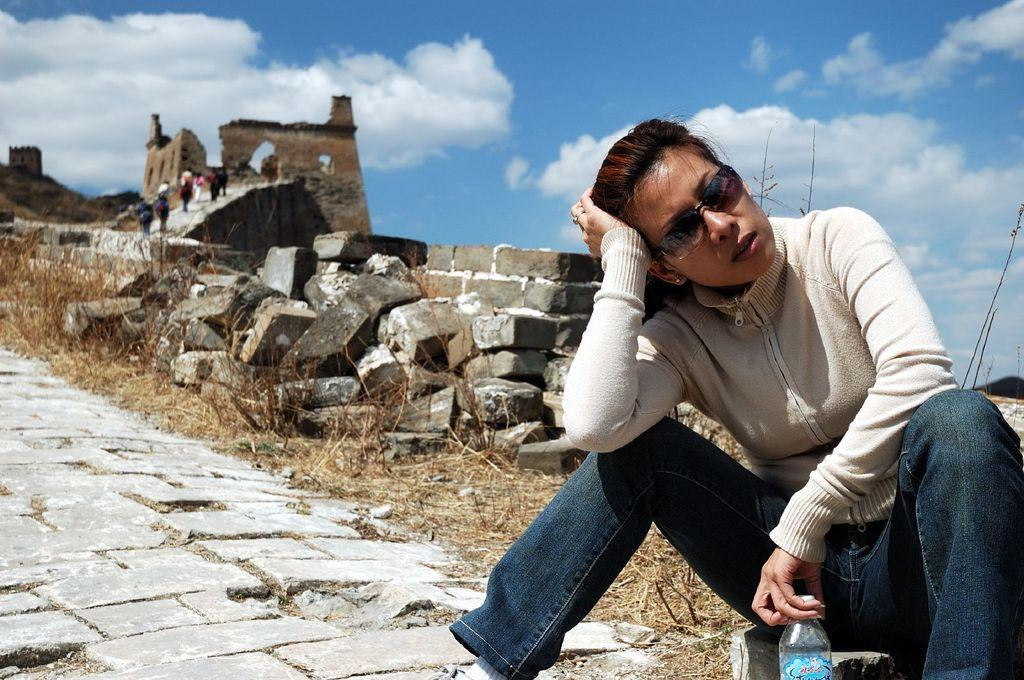What is the girl in the image doing? The girl is sitting on a rock in the image. What can be seen in the background of the image? There is a fort in the background of the image. What are the people in the image doing? The people in the image are walking on the fort. How does the girl pull the fort closer to her in the image? The girl does not pull the fort closer to her in the image; she is sitting on a rock, and the fort is in the background. 